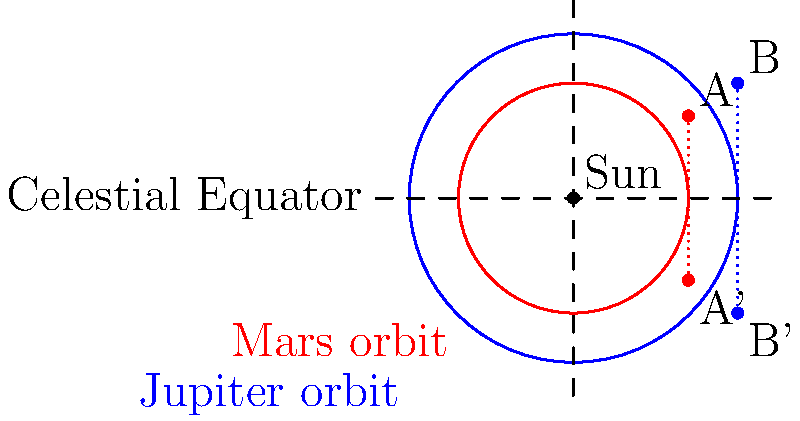In the celestial diagram above, the orbits of Mars (inner, red) and Jupiter (outer, blue) are shown relative to the Sun. Points A and B represent the current positions of Mars and Jupiter, respectively. If these positions are reflected across the celestial equator to A' and B', what is the ratio of the distance between the reflected points (A'B') to the original distance (AB), expressed as a simplified fraction? To solve this problem, we'll follow these steps:

1) First, recall that reflection across a line preserves distances and angles. This means that AB = A'B'.

2) The celestial equator acts as the axis of reflection, which is equivalent to the x-axis in a Cartesian coordinate system.

3) The coordinates of the points can be approximated from the diagram:
   A ≈ (0.7, 0.5)
   B ≈ (1, 0.7)

4) The reflected points will have the same x-coordinates, but opposite y-coordinates:
   A' ≈ (0.7, -0.5)
   B' ≈ (1, -0.7)

5) The distance AB can be calculated using the distance formula:
   $AB = \sqrt{(x_B - x_A)^2 + (y_B - y_A)^2}$
   $AB = \sqrt{(1 - 0.7)^2 + (0.7 - 0.5)^2}$
   $AB = \sqrt{0.3^2 + 0.2^2} = \sqrt{0.13}$

6) As mentioned in step 1, A'B' = AB = $\sqrt{0.13}$

7) The ratio of A'B' to AB is therefore:
   $\frac{A'B'}{AB} = \frac{\sqrt{0.13}}{\sqrt{0.13}} = 1$

Therefore, the ratio of the distance between the reflected points (A'B') to the original distance (AB) is 1:1 or simply 1.
Answer: 1 